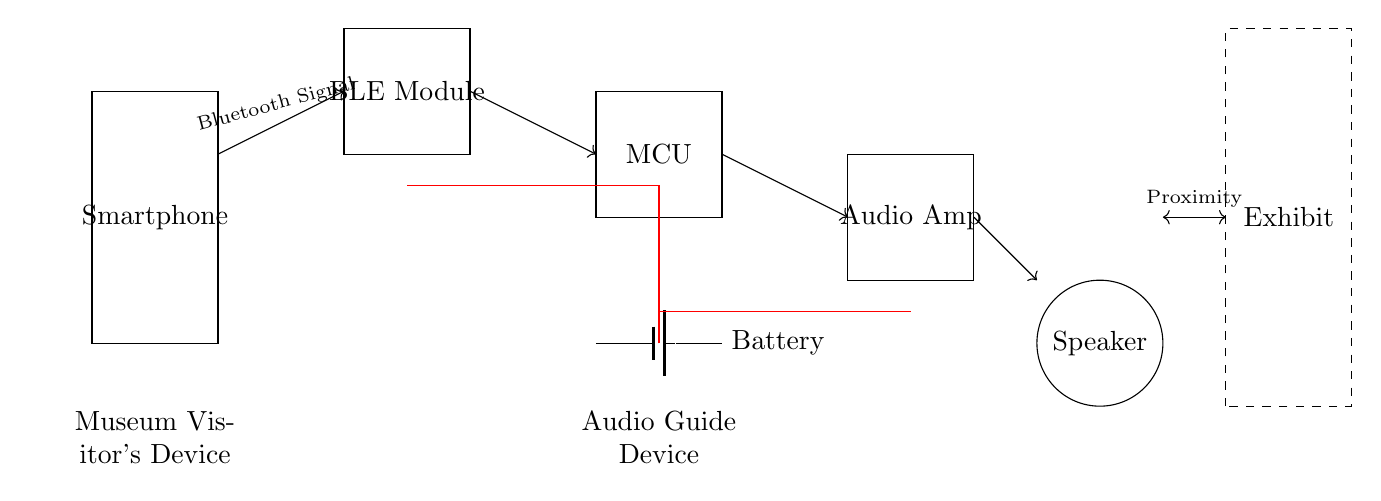What is the function of the BLE Module? The BLE Module serves to facilitate wireless communication between the smartphone and the microcontroller via Bluetooth Low Energy. It is designed to transmit audio signals efficiently over short distances.
Answer: Wireless communication What component powers the audio guide device? The component that powers the audio guide device is the battery, which supplies the necessary energy to all the connected components in the circuit.
Answer: Battery How many main components are in this circuit? The main components in the circuit include the smartphone, BLE module, microcontroller, audio amplifier, speaker, and battery, totaling six distinct components.
Answer: Six What type of signal does the BLE Module receive from the smartphone? The BLE Module receives a Bluetooth signal from the smartphone which contains audio data for playback through the audio guide device.
Answer: Bluetooth signal Which component amplifies the audio signal? The audio amplifier is the component responsible for increasing the volume of the audio signal before it is sent to the speaker for output.
Answer: Audio amplifier What is the primary purpose of the speaker in this circuit? The primary purpose of the speaker is to convert the amplified audio signal into sound, allowing museum visitors to hear the audio guide associated with the exhibits.
Answer: Sound output How does the audio guide system connect to the exhibit? The audio guide system connects to the exhibit through proximity, indicated by a double-headed arrow in the diagram, showing a relationship between the devices and the exhibit.
Answer: Proximity 